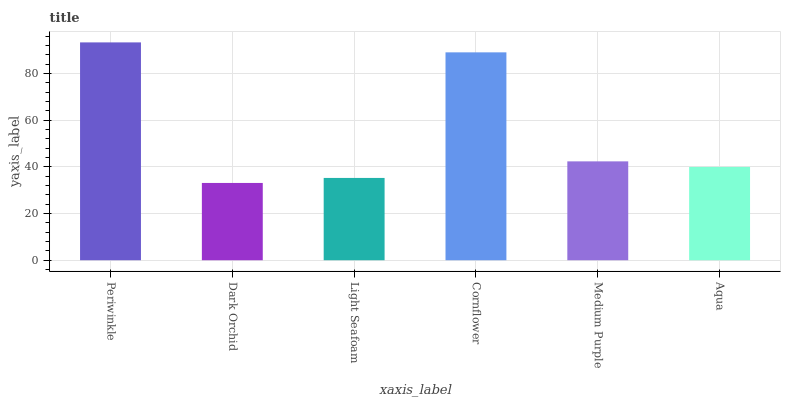Is Dark Orchid the minimum?
Answer yes or no. Yes. Is Periwinkle the maximum?
Answer yes or no. Yes. Is Light Seafoam the minimum?
Answer yes or no. No. Is Light Seafoam the maximum?
Answer yes or no. No. Is Light Seafoam greater than Dark Orchid?
Answer yes or no. Yes. Is Dark Orchid less than Light Seafoam?
Answer yes or no. Yes. Is Dark Orchid greater than Light Seafoam?
Answer yes or no. No. Is Light Seafoam less than Dark Orchid?
Answer yes or no. No. Is Medium Purple the high median?
Answer yes or no. Yes. Is Aqua the low median?
Answer yes or no. Yes. Is Periwinkle the high median?
Answer yes or no. No. Is Dark Orchid the low median?
Answer yes or no. No. 